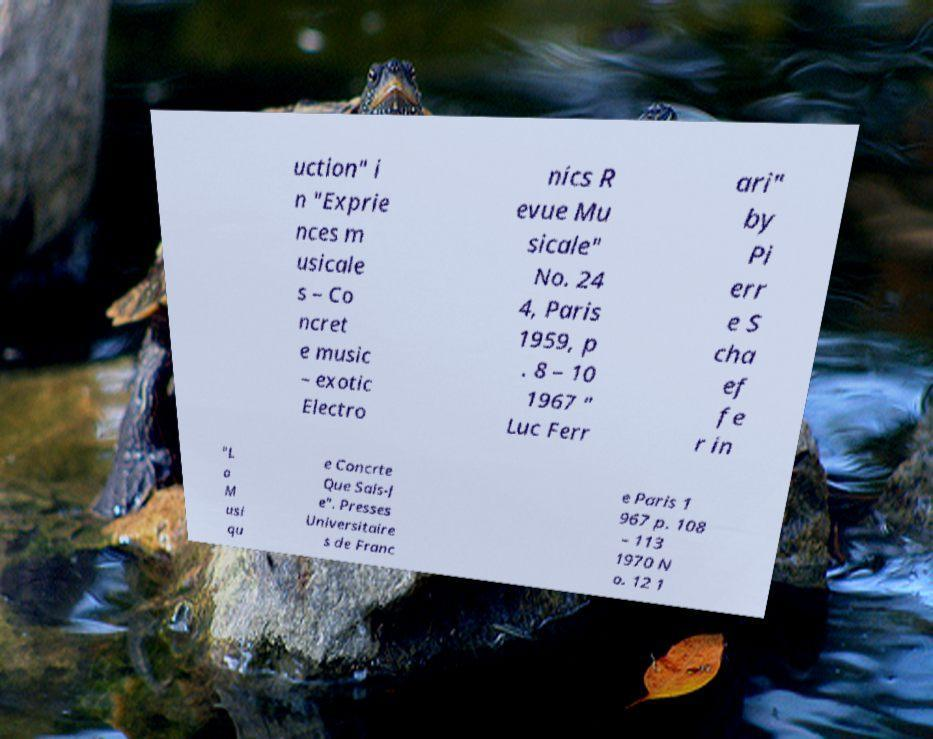Can you read and provide the text displayed in the image?This photo seems to have some interesting text. Can you extract and type it out for me? uction" i n "Exprie nces m usicale s – Co ncret e music – exotic Electro nics R evue Mu sicale" No. 24 4, Paris 1959, p . 8 – 10 1967 " Luc Ferr ari" by Pi err e S cha ef fe r in "L a M usi qu e Concrte Que Sais-J e". Presses Universitaire s de Franc e Paris 1 967 p. 108 – 113 1970 N o. 12 1 